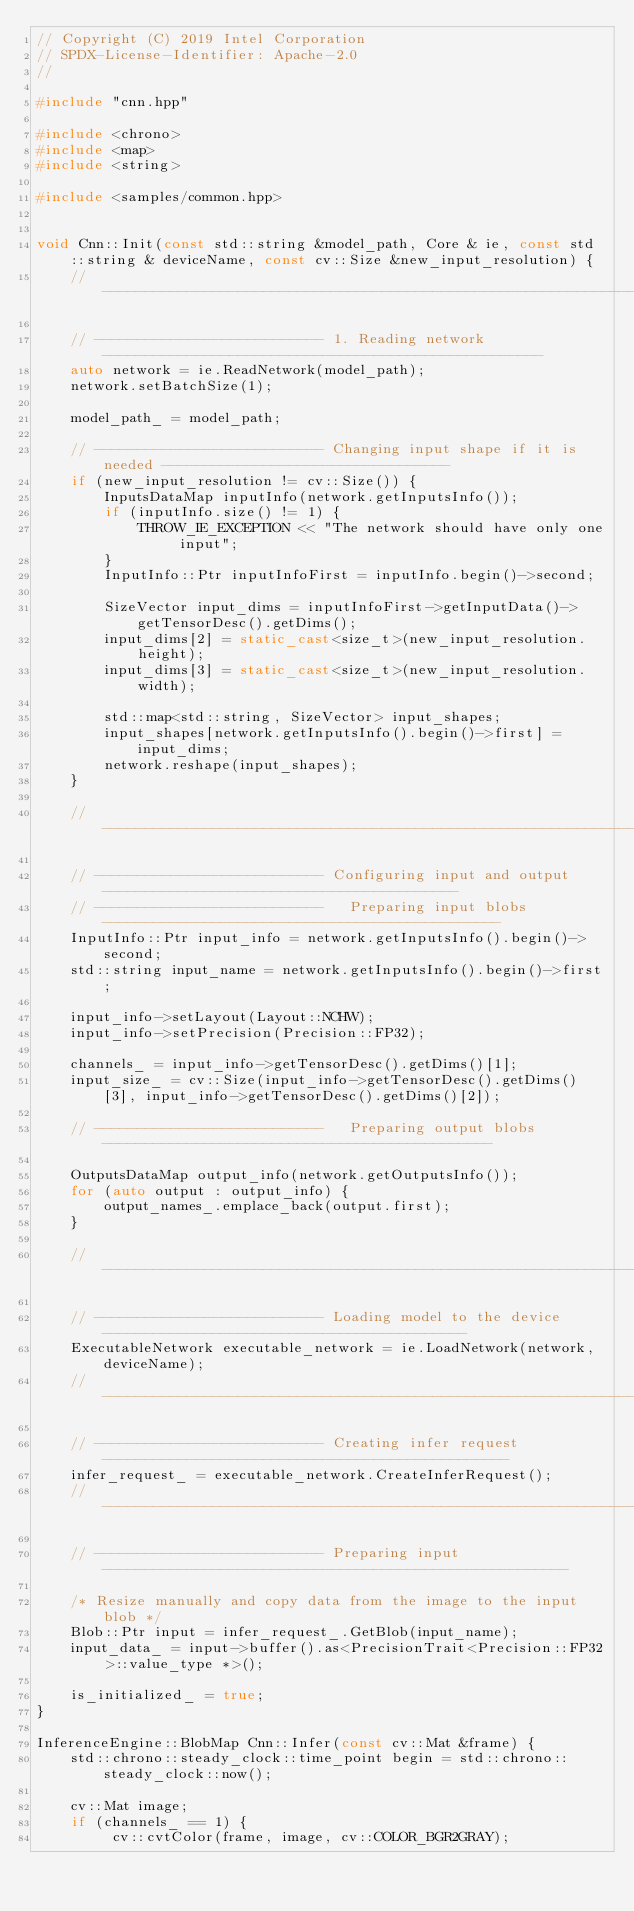Convert code to text. <code><loc_0><loc_0><loc_500><loc_500><_C++_>// Copyright (C) 2019 Intel Corporation
// SPDX-License-Identifier: Apache-2.0
//

#include "cnn.hpp"

#include <chrono>
#include <map>
#include <string>

#include <samples/common.hpp>


void Cnn::Init(const std::string &model_path, Core & ie, const std::string & deviceName, const cv::Size &new_input_resolution) {
    // ---------------------------------------------------------------------------------------------------

    // --------------------------- 1. Reading network ----------------------------------------------------
    auto network = ie.ReadNetwork(model_path);
    network.setBatchSize(1);

    model_path_ = model_path;

    // --------------------------- Changing input shape if it is needed ----------------------------------
    if (new_input_resolution != cv::Size()) {
        InputsDataMap inputInfo(network.getInputsInfo());
        if (inputInfo.size() != 1) {
            THROW_IE_EXCEPTION << "The network should have only one input";
        }
        InputInfo::Ptr inputInfoFirst = inputInfo.begin()->second;

        SizeVector input_dims = inputInfoFirst->getInputData()->getTensorDesc().getDims();
        input_dims[2] = static_cast<size_t>(new_input_resolution.height);
        input_dims[3] = static_cast<size_t>(new_input_resolution.width);

        std::map<std::string, SizeVector> input_shapes;
        input_shapes[network.getInputsInfo().begin()->first] = input_dims;
        network.reshape(input_shapes);
    }

    // ---------------------------------------------------------------------------------------------------

    // --------------------------- Configuring input and output ------------------------------------------
    // ---------------------------   Preparing input blobs -----------------------------------------------
    InputInfo::Ptr input_info = network.getInputsInfo().begin()->second;
    std::string input_name = network.getInputsInfo().begin()->first;

    input_info->setLayout(Layout::NCHW);
    input_info->setPrecision(Precision::FP32);

    channels_ = input_info->getTensorDesc().getDims()[1];
    input_size_ = cv::Size(input_info->getTensorDesc().getDims()[3], input_info->getTensorDesc().getDims()[2]);

    // ---------------------------   Preparing output blobs ----------------------------------------------

    OutputsDataMap output_info(network.getOutputsInfo());
    for (auto output : output_info) {
        output_names_.emplace_back(output.first);
    }

    // ---------------------------------------------------------------------------------------------------

    // --------------------------- Loading model to the device -------------------------------------------
    ExecutableNetwork executable_network = ie.LoadNetwork(network, deviceName);
    // ---------------------------------------------------------------------------------------------------

    // --------------------------- Creating infer request ------------------------------------------------
    infer_request_ = executable_network.CreateInferRequest();
    // ---------------------------------------------------------------------------------------------------

    // --------------------------- Preparing input -------------------------------------------------------

    /* Resize manually and copy data from the image to the input blob */
    Blob::Ptr input = infer_request_.GetBlob(input_name);
    input_data_ = input->buffer().as<PrecisionTrait<Precision::FP32>::value_type *>();

    is_initialized_ = true;
}

InferenceEngine::BlobMap Cnn::Infer(const cv::Mat &frame) {
    std::chrono::steady_clock::time_point begin = std::chrono::steady_clock::now();

    cv::Mat image;
    if (channels_ == 1) {
         cv::cvtColor(frame, image, cv::COLOR_BGR2GRAY);</code> 